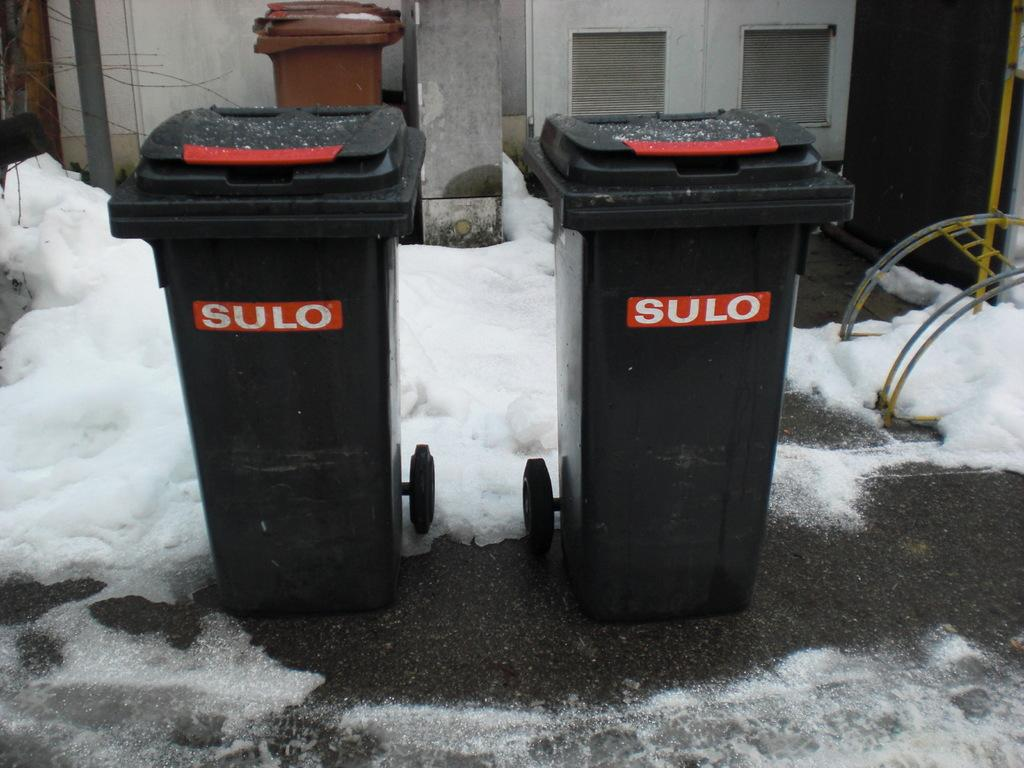<image>
Present a compact description of the photo's key features. Two trash dumpsters sitting outside have SULO on the front of them. 